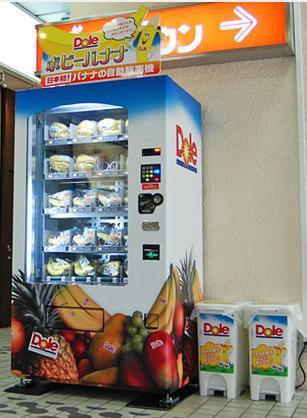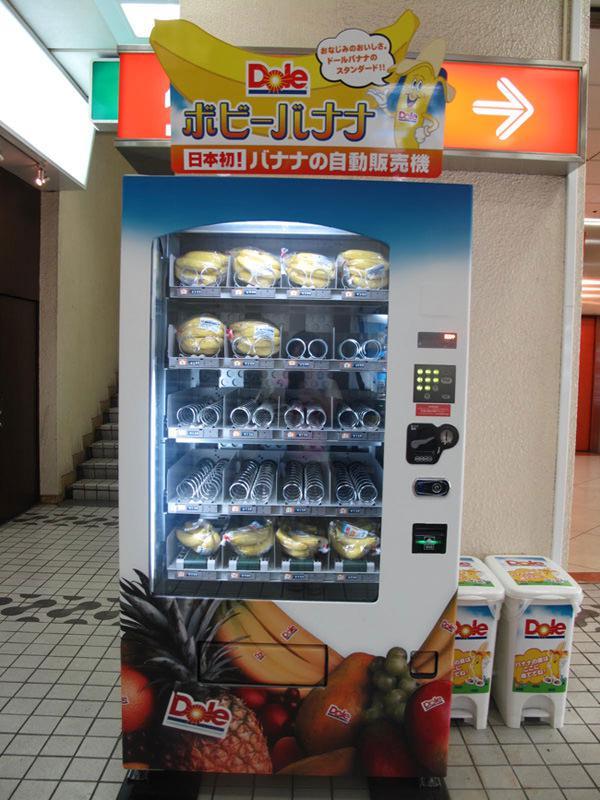The first image is the image on the left, the second image is the image on the right. Given the left and right images, does the statement "Two trashcans are visible beside the vending machine in the image on the left." hold true? Answer yes or no. Yes. 